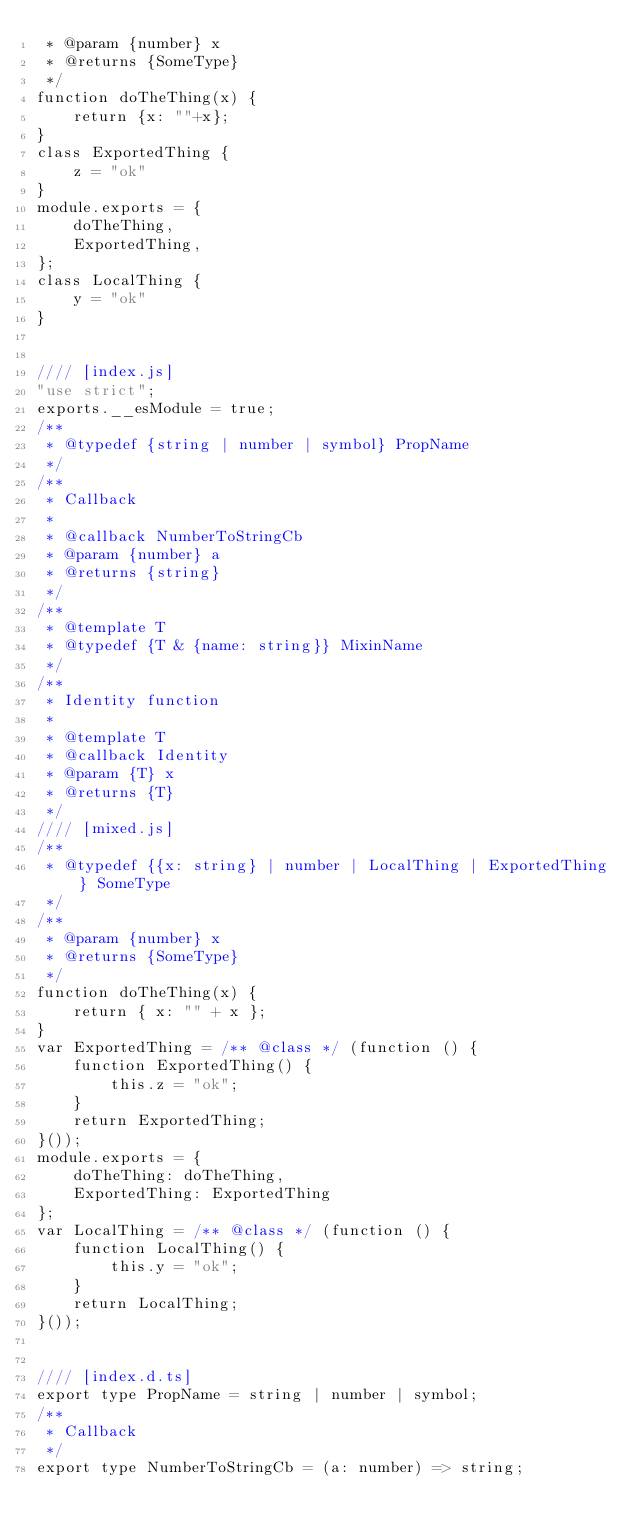Convert code to text. <code><loc_0><loc_0><loc_500><loc_500><_JavaScript_> * @param {number} x
 * @returns {SomeType}
 */
function doTheThing(x) {
    return {x: ""+x};
}
class ExportedThing {
    z = "ok"
}
module.exports = {
    doTheThing,
    ExportedThing,
};
class LocalThing {
    y = "ok"
}


//// [index.js]
"use strict";
exports.__esModule = true;
/**
 * @typedef {string | number | symbol} PropName
 */
/**
 * Callback
 *
 * @callback NumberToStringCb
 * @param {number} a
 * @returns {string}
 */
/**
 * @template T
 * @typedef {T & {name: string}} MixinName
 */
/**
 * Identity function
 *
 * @template T
 * @callback Identity
 * @param {T} x
 * @returns {T}
 */
//// [mixed.js]
/**
 * @typedef {{x: string} | number | LocalThing | ExportedThing} SomeType
 */
/**
 * @param {number} x
 * @returns {SomeType}
 */
function doTheThing(x) {
    return { x: "" + x };
}
var ExportedThing = /** @class */ (function () {
    function ExportedThing() {
        this.z = "ok";
    }
    return ExportedThing;
}());
module.exports = {
    doTheThing: doTheThing,
    ExportedThing: ExportedThing
};
var LocalThing = /** @class */ (function () {
    function LocalThing() {
        this.y = "ok";
    }
    return LocalThing;
}());


//// [index.d.ts]
export type PropName = string | number | symbol;
/**
 * Callback
 */
export type NumberToStringCb = (a: number) => string;</code> 